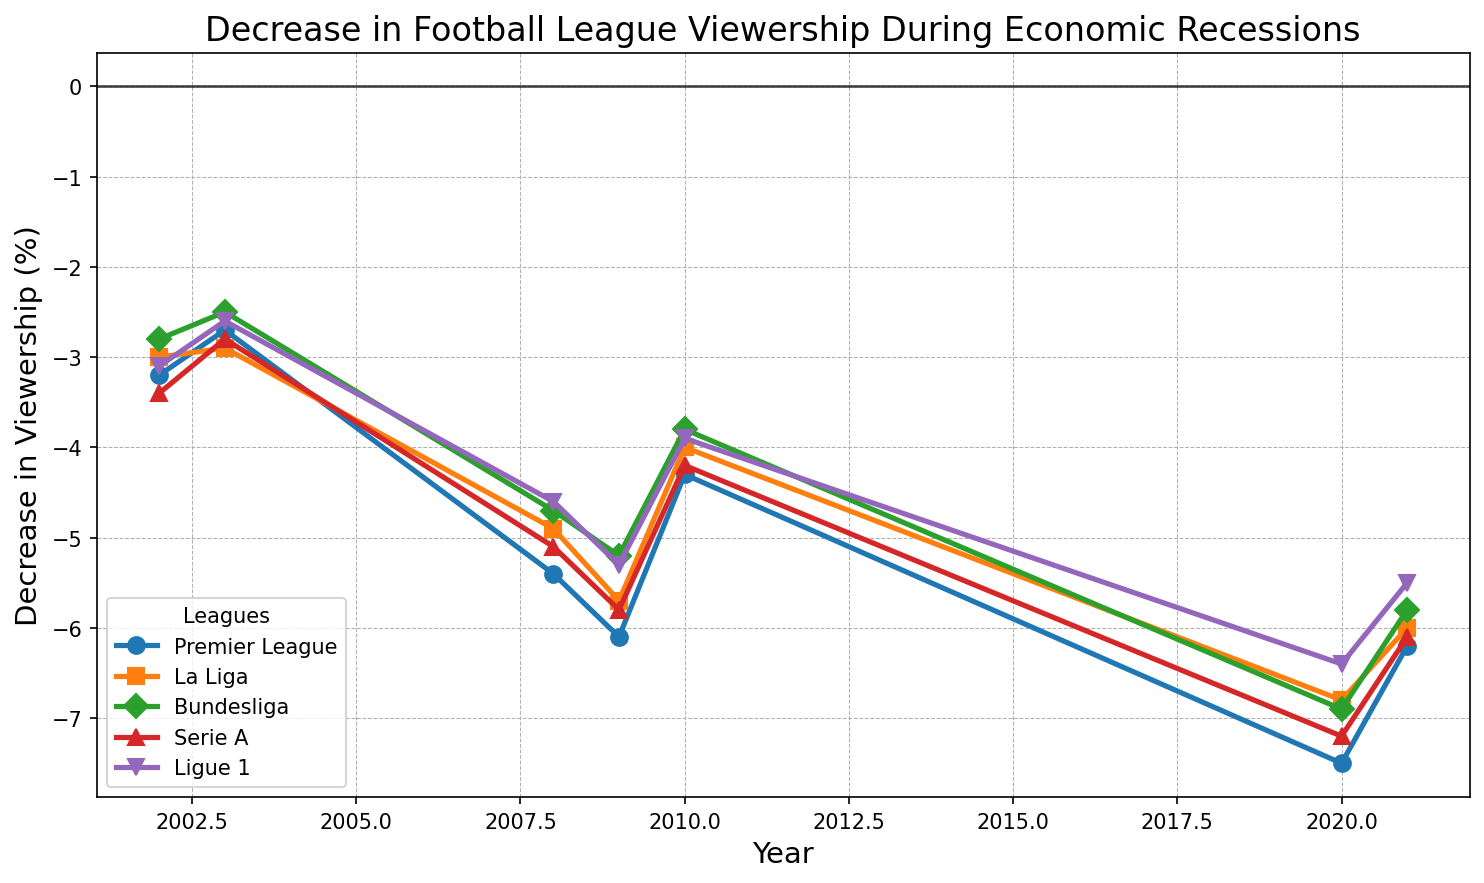what's the difference in viewership decrease between Premier League and La Liga in 2009? The figure shows both leagues' viewership decreases in 2009: Premier League (-6.1%) and La Liga (-5.7%). The difference is -6.1 - (-5.7) = -0.4.
Answer: -0.4 Which league experienced the highest viewership decrease in 2020? By observing the lines and markers on the figure for 2020, the Premier League shows the highest decrease at -7.5%.
Answer: Premier League What was the average decrease in viewership for Serie A during 2008 and 2009? Serie A had a decrease of -5.1% in 2008 and -5.8% in 2009. The average is (-5.1 + -5.8) / 2 = -5.45.
Answer: -5.45 Between which years did the Bundesliga see the most significant improvement in viewership decrease? By comparing the changes across pairs of years, Bundesliga had the most significant improvement from 2009 to 2010, changing from -5.2% to -3.8%, an improvement of 1.4.
Answer: 2009 to 2010 How did the viewership decrease for Ligue 1 in 2021 compare to 2020? The figure shows Ligue 1 had -6.4% in 2020 and -5.5% in 2021. The decrease improved by 0.9 in 2021 compared to 2020.
Answer: Improved by 0.9 Which years show a simultaneous improvement in viewership decrease for all five leagues? From the figure, all leagues show an improvement between 2009 and 2010: Premier League (-6.1 to -4.3), La Liga (-5.7 to -4.0), Bundesliga (-5.2 to -3.8), Serie A (-5.8 to -4.2), Ligue 1 (-5.3 to -3.9).
Answer: 2009 to 2010 What is the trend in viewership decrease for Serie A between 2002 and 2021? Observing the Serie A line, it decreases from 2002 to 2003, increases significantly from 2008 to 2009, improves from 2009 to 2010, and then drops again in 2020, and improves slightly in 2021. The trend shows fluctuation with notable peaks in 2009 and 2020.
Answer: Fluctuating with peaks in 2009 and 2020 Which league had the smallest decrease in viewership in 2003? By examining the markers for 2003, Bundesliga had the smallest decrease at -2.5%.
Answer: Bundesliga What is the cumulative decrease in viewership for La Liga from 2002 to 2021? Summing the decreases for La Liga from the figure: -3.0 - 2.9 - 4.9 - 5.7 - 4.0 - 6.8 - 6.0 gives a cumulative decrease of -33.3.
Answer: -33.3 How does the 2008-2009 recession impact on Bundesliga compare to the 2020-2021 period? For 2008-2009, Bundesliga decreases by -4.7% to -5.2%, a change of -0.5. For 2020-2021, it changes from -6.9% to -5.8%, improving by 1.1. Thus, the impact was worse during 2020-2021.
Answer: Worse in 2020-2021 